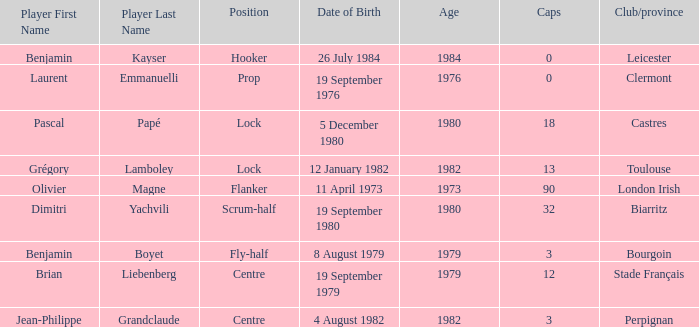What is the location of perpignan? Centre. 